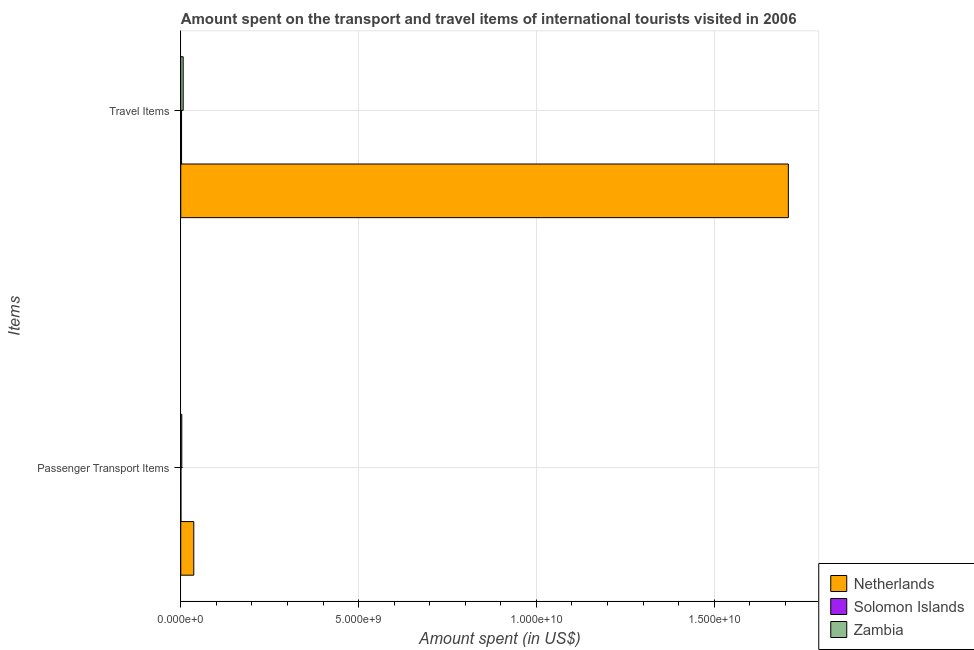How many different coloured bars are there?
Offer a terse response. 3. How many bars are there on the 1st tick from the top?
Give a very brief answer. 3. How many bars are there on the 1st tick from the bottom?
Your answer should be compact. 3. What is the label of the 1st group of bars from the top?
Make the answer very short. Travel Items. What is the amount spent on passenger transport items in Zambia?
Make the answer very short. 2.90e+07. Across all countries, what is the maximum amount spent on passenger transport items?
Your answer should be very brief. 3.66e+08. Across all countries, what is the minimum amount spent on passenger transport items?
Offer a very short reply. 4.30e+06. In which country was the amount spent on passenger transport items minimum?
Offer a very short reply. Solomon Islands. What is the total amount spent in travel items in the graph?
Provide a short and direct response. 1.72e+1. What is the difference between the amount spent on passenger transport items in Netherlands and that in Zambia?
Provide a short and direct response. 3.37e+08. What is the difference between the amount spent on passenger transport items in Solomon Islands and the amount spent in travel items in Netherlands?
Keep it short and to the point. -1.71e+1. What is the average amount spent on passenger transport items per country?
Keep it short and to the point. 1.33e+08. What is the difference between the amount spent on passenger transport items and amount spent in travel items in Zambia?
Provide a short and direct response. -3.90e+07. In how many countries, is the amount spent on passenger transport items greater than 10000000000 US$?
Your answer should be compact. 0. What is the ratio of the amount spent on passenger transport items in Netherlands to that in Solomon Islands?
Ensure brevity in your answer.  85.12. Is the amount spent in travel items in Netherlands less than that in Solomon Islands?
Offer a terse response. No. In how many countries, is the amount spent in travel items greater than the average amount spent in travel items taken over all countries?
Ensure brevity in your answer.  1. What does the 1st bar from the top in Travel Items represents?
Provide a succinct answer. Zambia. What does the 2nd bar from the bottom in Travel Items represents?
Provide a short and direct response. Solomon Islands. How many bars are there?
Ensure brevity in your answer.  6. How many countries are there in the graph?
Offer a very short reply. 3. What is the difference between two consecutive major ticks on the X-axis?
Offer a terse response. 5.00e+09. Does the graph contain any zero values?
Make the answer very short. No. Does the graph contain grids?
Provide a succinct answer. Yes. Where does the legend appear in the graph?
Keep it short and to the point. Bottom right. How many legend labels are there?
Your answer should be very brief. 3. What is the title of the graph?
Provide a succinct answer. Amount spent on the transport and travel items of international tourists visited in 2006. Does "Panama" appear as one of the legend labels in the graph?
Your answer should be compact. No. What is the label or title of the X-axis?
Provide a short and direct response. Amount spent (in US$). What is the label or title of the Y-axis?
Give a very brief answer. Items. What is the Amount spent (in US$) in Netherlands in Passenger Transport Items?
Ensure brevity in your answer.  3.66e+08. What is the Amount spent (in US$) in Solomon Islands in Passenger Transport Items?
Offer a terse response. 4.30e+06. What is the Amount spent (in US$) of Zambia in Passenger Transport Items?
Give a very brief answer. 2.90e+07. What is the Amount spent (in US$) of Netherlands in Travel Items?
Your response must be concise. 1.71e+1. What is the Amount spent (in US$) of Solomon Islands in Travel Items?
Ensure brevity in your answer.  2.22e+07. What is the Amount spent (in US$) in Zambia in Travel Items?
Make the answer very short. 6.80e+07. Across all Items, what is the maximum Amount spent (in US$) of Netherlands?
Your response must be concise. 1.71e+1. Across all Items, what is the maximum Amount spent (in US$) of Solomon Islands?
Offer a terse response. 2.22e+07. Across all Items, what is the maximum Amount spent (in US$) in Zambia?
Offer a terse response. 6.80e+07. Across all Items, what is the minimum Amount spent (in US$) in Netherlands?
Offer a very short reply. 3.66e+08. Across all Items, what is the minimum Amount spent (in US$) in Solomon Islands?
Give a very brief answer. 4.30e+06. Across all Items, what is the minimum Amount spent (in US$) of Zambia?
Ensure brevity in your answer.  2.90e+07. What is the total Amount spent (in US$) of Netherlands in the graph?
Provide a succinct answer. 1.75e+1. What is the total Amount spent (in US$) of Solomon Islands in the graph?
Your answer should be compact. 2.65e+07. What is the total Amount spent (in US$) in Zambia in the graph?
Give a very brief answer. 9.70e+07. What is the difference between the Amount spent (in US$) in Netherlands in Passenger Transport Items and that in Travel Items?
Offer a terse response. -1.67e+1. What is the difference between the Amount spent (in US$) in Solomon Islands in Passenger Transport Items and that in Travel Items?
Offer a terse response. -1.79e+07. What is the difference between the Amount spent (in US$) in Zambia in Passenger Transport Items and that in Travel Items?
Make the answer very short. -3.90e+07. What is the difference between the Amount spent (in US$) of Netherlands in Passenger Transport Items and the Amount spent (in US$) of Solomon Islands in Travel Items?
Offer a very short reply. 3.44e+08. What is the difference between the Amount spent (in US$) in Netherlands in Passenger Transport Items and the Amount spent (in US$) in Zambia in Travel Items?
Provide a short and direct response. 2.98e+08. What is the difference between the Amount spent (in US$) in Solomon Islands in Passenger Transport Items and the Amount spent (in US$) in Zambia in Travel Items?
Offer a very short reply. -6.37e+07. What is the average Amount spent (in US$) in Netherlands per Items?
Your answer should be compact. 8.73e+09. What is the average Amount spent (in US$) of Solomon Islands per Items?
Your answer should be very brief. 1.32e+07. What is the average Amount spent (in US$) in Zambia per Items?
Offer a very short reply. 4.85e+07. What is the difference between the Amount spent (in US$) of Netherlands and Amount spent (in US$) of Solomon Islands in Passenger Transport Items?
Your answer should be very brief. 3.62e+08. What is the difference between the Amount spent (in US$) in Netherlands and Amount spent (in US$) in Zambia in Passenger Transport Items?
Offer a terse response. 3.37e+08. What is the difference between the Amount spent (in US$) in Solomon Islands and Amount spent (in US$) in Zambia in Passenger Transport Items?
Provide a short and direct response. -2.47e+07. What is the difference between the Amount spent (in US$) in Netherlands and Amount spent (in US$) in Solomon Islands in Travel Items?
Give a very brief answer. 1.71e+1. What is the difference between the Amount spent (in US$) in Netherlands and Amount spent (in US$) in Zambia in Travel Items?
Provide a succinct answer. 1.70e+1. What is the difference between the Amount spent (in US$) in Solomon Islands and Amount spent (in US$) in Zambia in Travel Items?
Offer a terse response. -4.58e+07. What is the ratio of the Amount spent (in US$) in Netherlands in Passenger Transport Items to that in Travel Items?
Offer a terse response. 0.02. What is the ratio of the Amount spent (in US$) of Solomon Islands in Passenger Transport Items to that in Travel Items?
Offer a very short reply. 0.19. What is the ratio of the Amount spent (in US$) in Zambia in Passenger Transport Items to that in Travel Items?
Keep it short and to the point. 0.43. What is the difference between the highest and the second highest Amount spent (in US$) in Netherlands?
Offer a terse response. 1.67e+1. What is the difference between the highest and the second highest Amount spent (in US$) of Solomon Islands?
Provide a short and direct response. 1.79e+07. What is the difference between the highest and the second highest Amount spent (in US$) of Zambia?
Provide a short and direct response. 3.90e+07. What is the difference between the highest and the lowest Amount spent (in US$) of Netherlands?
Offer a terse response. 1.67e+1. What is the difference between the highest and the lowest Amount spent (in US$) in Solomon Islands?
Your answer should be very brief. 1.79e+07. What is the difference between the highest and the lowest Amount spent (in US$) in Zambia?
Your response must be concise. 3.90e+07. 